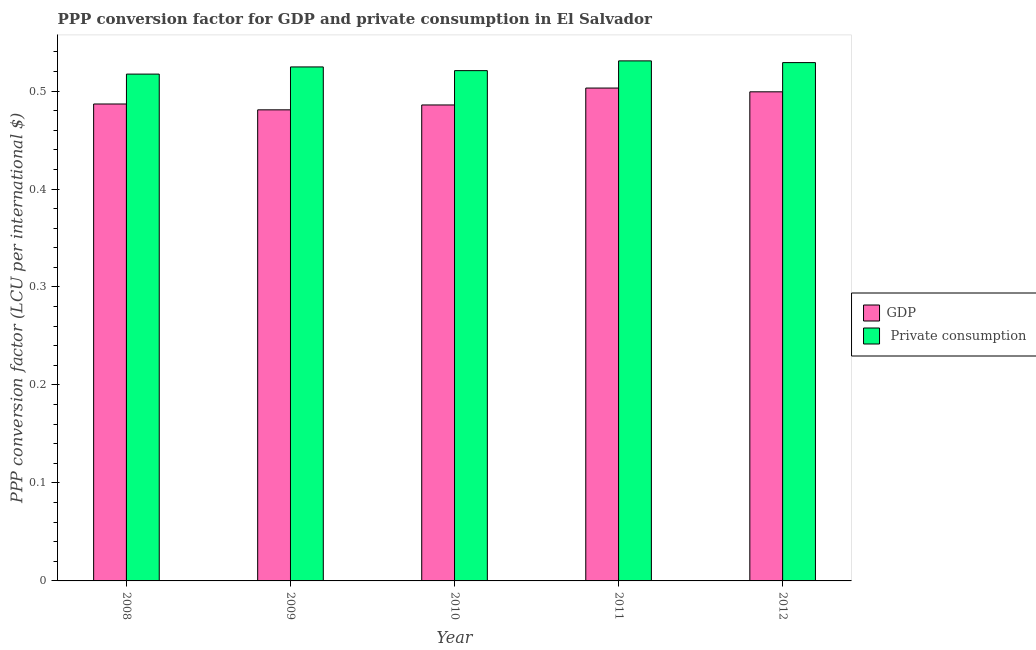How many groups of bars are there?
Provide a short and direct response. 5. Are the number of bars on each tick of the X-axis equal?
Offer a very short reply. Yes. How many bars are there on the 4th tick from the left?
Keep it short and to the point. 2. What is the label of the 4th group of bars from the left?
Make the answer very short. 2011. In how many cases, is the number of bars for a given year not equal to the number of legend labels?
Keep it short and to the point. 0. What is the ppp conversion factor for private consumption in 2010?
Your response must be concise. 0.52. Across all years, what is the maximum ppp conversion factor for private consumption?
Offer a very short reply. 0.53. Across all years, what is the minimum ppp conversion factor for gdp?
Ensure brevity in your answer.  0.48. In which year was the ppp conversion factor for gdp maximum?
Your answer should be compact. 2011. In which year was the ppp conversion factor for private consumption minimum?
Provide a short and direct response. 2008. What is the total ppp conversion factor for private consumption in the graph?
Your response must be concise. 2.62. What is the difference between the ppp conversion factor for private consumption in 2008 and that in 2012?
Provide a short and direct response. -0.01. What is the difference between the ppp conversion factor for gdp in 2012 and the ppp conversion factor for private consumption in 2009?
Make the answer very short. 0.02. What is the average ppp conversion factor for private consumption per year?
Give a very brief answer. 0.52. What is the ratio of the ppp conversion factor for private consumption in 2011 to that in 2012?
Keep it short and to the point. 1. What is the difference between the highest and the second highest ppp conversion factor for gdp?
Give a very brief answer. 0. What is the difference between the highest and the lowest ppp conversion factor for gdp?
Provide a succinct answer. 0.02. What does the 1st bar from the left in 2011 represents?
Keep it short and to the point. GDP. What does the 2nd bar from the right in 2008 represents?
Make the answer very short. GDP. Are all the bars in the graph horizontal?
Provide a succinct answer. No. What is the difference between two consecutive major ticks on the Y-axis?
Ensure brevity in your answer.  0.1. Does the graph contain any zero values?
Your response must be concise. No. Does the graph contain grids?
Provide a succinct answer. No. How are the legend labels stacked?
Ensure brevity in your answer.  Vertical. What is the title of the graph?
Ensure brevity in your answer.  PPP conversion factor for GDP and private consumption in El Salvador. What is the label or title of the X-axis?
Your answer should be very brief. Year. What is the label or title of the Y-axis?
Offer a terse response. PPP conversion factor (LCU per international $). What is the PPP conversion factor (LCU per international $) in GDP in 2008?
Provide a succinct answer. 0.49. What is the PPP conversion factor (LCU per international $) of  Private consumption in 2008?
Offer a very short reply. 0.52. What is the PPP conversion factor (LCU per international $) in GDP in 2009?
Offer a terse response. 0.48. What is the PPP conversion factor (LCU per international $) of  Private consumption in 2009?
Your answer should be very brief. 0.52. What is the PPP conversion factor (LCU per international $) of GDP in 2010?
Provide a succinct answer. 0.49. What is the PPP conversion factor (LCU per international $) in  Private consumption in 2010?
Your response must be concise. 0.52. What is the PPP conversion factor (LCU per international $) in GDP in 2011?
Offer a terse response. 0.5. What is the PPP conversion factor (LCU per international $) in  Private consumption in 2011?
Keep it short and to the point. 0.53. What is the PPP conversion factor (LCU per international $) in GDP in 2012?
Provide a succinct answer. 0.5. What is the PPP conversion factor (LCU per international $) in  Private consumption in 2012?
Make the answer very short. 0.53. Across all years, what is the maximum PPP conversion factor (LCU per international $) in GDP?
Your answer should be very brief. 0.5. Across all years, what is the maximum PPP conversion factor (LCU per international $) of  Private consumption?
Your response must be concise. 0.53. Across all years, what is the minimum PPP conversion factor (LCU per international $) of GDP?
Your answer should be compact. 0.48. Across all years, what is the minimum PPP conversion factor (LCU per international $) in  Private consumption?
Your response must be concise. 0.52. What is the total PPP conversion factor (LCU per international $) in GDP in the graph?
Offer a very short reply. 2.46. What is the total PPP conversion factor (LCU per international $) of  Private consumption in the graph?
Offer a terse response. 2.62. What is the difference between the PPP conversion factor (LCU per international $) in GDP in 2008 and that in 2009?
Keep it short and to the point. 0.01. What is the difference between the PPP conversion factor (LCU per international $) in  Private consumption in 2008 and that in 2009?
Offer a very short reply. -0.01. What is the difference between the PPP conversion factor (LCU per international $) in  Private consumption in 2008 and that in 2010?
Your response must be concise. -0. What is the difference between the PPP conversion factor (LCU per international $) of GDP in 2008 and that in 2011?
Your response must be concise. -0.02. What is the difference between the PPP conversion factor (LCU per international $) of  Private consumption in 2008 and that in 2011?
Keep it short and to the point. -0.01. What is the difference between the PPP conversion factor (LCU per international $) of GDP in 2008 and that in 2012?
Keep it short and to the point. -0.01. What is the difference between the PPP conversion factor (LCU per international $) in  Private consumption in 2008 and that in 2012?
Offer a terse response. -0.01. What is the difference between the PPP conversion factor (LCU per international $) of GDP in 2009 and that in 2010?
Your answer should be compact. -0.01. What is the difference between the PPP conversion factor (LCU per international $) of  Private consumption in 2009 and that in 2010?
Your answer should be very brief. 0. What is the difference between the PPP conversion factor (LCU per international $) of GDP in 2009 and that in 2011?
Ensure brevity in your answer.  -0.02. What is the difference between the PPP conversion factor (LCU per international $) in  Private consumption in 2009 and that in 2011?
Make the answer very short. -0.01. What is the difference between the PPP conversion factor (LCU per international $) in GDP in 2009 and that in 2012?
Give a very brief answer. -0.02. What is the difference between the PPP conversion factor (LCU per international $) of  Private consumption in 2009 and that in 2012?
Make the answer very short. -0. What is the difference between the PPP conversion factor (LCU per international $) in GDP in 2010 and that in 2011?
Your answer should be very brief. -0.02. What is the difference between the PPP conversion factor (LCU per international $) of  Private consumption in 2010 and that in 2011?
Ensure brevity in your answer.  -0.01. What is the difference between the PPP conversion factor (LCU per international $) of GDP in 2010 and that in 2012?
Offer a terse response. -0.01. What is the difference between the PPP conversion factor (LCU per international $) of  Private consumption in 2010 and that in 2012?
Offer a terse response. -0.01. What is the difference between the PPP conversion factor (LCU per international $) in GDP in 2011 and that in 2012?
Provide a succinct answer. 0. What is the difference between the PPP conversion factor (LCU per international $) of  Private consumption in 2011 and that in 2012?
Keep it short and to the point. 0. What is the difference between the PPP conversion factor (LCU per international $) in GDP in 2008 and the PPP conversion factor (LCU per international $) in  Private consumption in 2009?
Ensure brevity in your answer.  -0.04. What is the difference between the PPP conversion factor (LCU per international $) of GDP in 2008 and the PPP conversion factor (LCU per international $) of  Private consumption in 2010?
Your response must be concise. -0.03. What is the difference between the PPP conversion factor (LCU per international $) in GDP in 2008 and the PPP conversion factor (LCU per international $) in  Private consumption in 2011?
Ensure brevity in your answer.  -0.04. What is the difference between the PPP conversion factor (LCU per international $) of GDP in 2008 and the PPP conversion factor (LCU per international $) of  Private consumption in 2012?
Ensure brevity in your answer.  -0.04. What is the difference between the PPP conversion factor (LCU per international $) of GDP in 2009 and the PPP conversion factor (LCU per international $) of  Private consumption in 2010?
Give a very brief answer. -0.04. What is the difference between the PPP conversion factor (LCU per international $) of GDP in 2009 and the PPP conversion factor (LCU per international $) of  Private consumption in 2012?
Give a very brief answer. -0.05. What is the difference between the PPP conversion factor (LCU per international $) in GDP in 2010 and the PPP conversion factor (LCU per international $) in  Private consumption in 2011?
Offer a terse response. -0.04. What is the difference between the PPP conversion factor (LCU per international $) of GDP in 2010 and the PPP conversion factor (LCU per international $) of  Private consumption in 2012?
Provide a succinct answer. -0.04. What is the difference between the PPP conversion factor (LCU per international $) in GDP in 2011 and the PPP conversion factor (LCU per international $) in  Private consumption in 2012?
Offer a terse response. -0.03. What is the average PPP conversion factor (LCU per international $) in GDP per year?
Keep it short and to the point. 0.49. What is the average PPP conversion factor (LCU per international $) in  Private consumption per year?
Offer a very short reply. 0.52. In the year 2008, what is the difference between the PPP conversion factor (LCU per international $) of GDP and PPP conversion factor (LCU per international $) of  Private consumption?
Offer a terse response. -0.03. In the year 2009, what is the difference between the PPP conversion factor (LCU per international $) in GDP and PPP conversion factor (LCU per international $) in  Private consumption?
Provide a short and direct response. -0.04. In the year 2010, what is the difference between the PPP conversion factor (LCU per international $) of GDP and PPP conversion factor (LCU per international $) of  Private consumption?
Give a very brief answer. -0.04. In the year 2011, what is the difference between the PPP conversion factor (LCU per international $) of GDP and PPP conversion factor (LCU per international $) of  Private consumption?
Give a very brief answer. -0.03. In the year 2012, what is the difference between the PPP conversion factor (LCU per international $) in GDP and PPP conversion factor (LCU per international $) in  Private consumption?
Offer a terse response. -0.03. What is the ratio of the PPP conversion factor (LCU per international $) in GDP in 2008 to that in 2009?
Give a very brief answer. 1.01. What is the ratio of the PPP conversion factor (LCU per international $) in  Private consumption in 2008 to that in 2009?
Your response must be concise. 0.99. What is the ratio of the PPP conversion factor (LCU per international $) of GDP in 2008 to that in 2010?
Your response must be concise. 1. What is the ratio of the PPP conversion factor (LCU per international $) of GDP in 2008 to that in 2011?
Ensure brevity in your answer.  0.97. What is the ratio of the PPP conversion factor (LCU per international $) in  Private consumption in 2008 to that in 2011?
Your answer should be compact. 0.97. What is the ratio of the PPP conversion factor (LCU per international $) of GDP in 2008 to that in 2012?
Provide a succinct answer. 0.98. What is the ratio of the PPP conversion factor (LCU per international $) in  Private consumption in 2008 to that in 2012?
Provide a succinct answer. 0.98. What is the ratio of the PPP conversion factor (LCU per international $) of GDP in 2009 to that in 2010?
Provide a succinct answer. 0.99. What is the ratio of the PPP conversion factor (LCU per international $) in  Private consumption in 2009 to that in 2010?
Give a very brief answer. 1.01. What is the ratio of the PPP conversion factor (LCU per international $) in GDP in 2009 to that in 2011?
Make the answer very short. 0.96. What is the ratio of the PPP conversion factor (LCU per international $) in  Private consumption in 2009 to that in 2011?
Ensure brevity in your answer.  0.99. What is the ratio of the PPP conversion factor (LCU per international $) in GDP in 2009 to that in 2012?
Provide a short and direct response. 0.96. What is the ratio of the PPP conversion factor (LCU per international $) in GDP in 2010 to that in 2011?
Offer a very short reply. 0.97. What is the ratio of the PPP conversion factor (LCU per international $) in  Private consumption in 2010 to that in 2011?
Your answer should be compact. 0.98. What is the ratio of the PPP conversion factor (LCU per international $) of GDP in 2010 to that in 2012?
Your response must be concise. 0.97. What is the ratio of the PPP conversion factor (LCU per international $) in  Private consumption in 2010 to that in 2012?
Ensure brevity in your answer.  0.98. What is the ratio of the PPP conversion factor (LCU per international $) of GDP in 2011 to that in 2012?
Offer a terse response. 1.01. What is the difference between the highest and the second highest PPP conversion factor (LCU per international $) in GDP?
Your answer should be compact. 0. What is the difference between the highest and the second highest PPP conversion factor (LCU per international $) in  Private consumption?
Ensure brevity in your answer.  0. What is the difference between the highest and the lowest PPP conversion factor (LCU per international $) in GDP?
Provide a succinct answer. 0.02. What is the difference between the highest and the lowest PPP conversion factor (LCU per international $) of  Private consumption?
Make the answer very short. 0.01. 